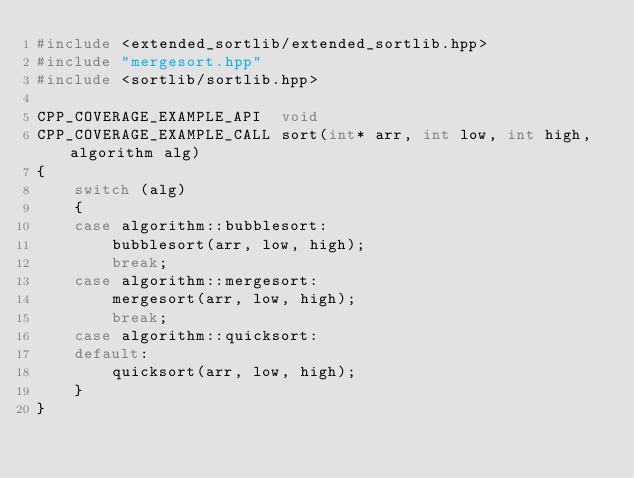Convert code to text. <code><loc_0><loc_0><loc_500><loc_500><_C++_>#include <extended_sortlib/extended_sortlib.hpp>
#include "mergesort.hpp"
#include <sortlib/sortlib.hpp>

CPP_COVERAGE_EXAMPLE_API  void
CPP_COVERAGE_EXAMPLE_CALL sort(int* arr, int low, int high, algorithm alg)
{
    switch (alg)
    {
    case algorithm::bubblesort:
        bubblesort(arr, low, high);
        break;
    case algorithm::mergesort:
        mergesort(arr, low, high);
        break;
    case algorithm::quicksort:
    default:
        quicksort(arr, low, high);
    }
}</code> 